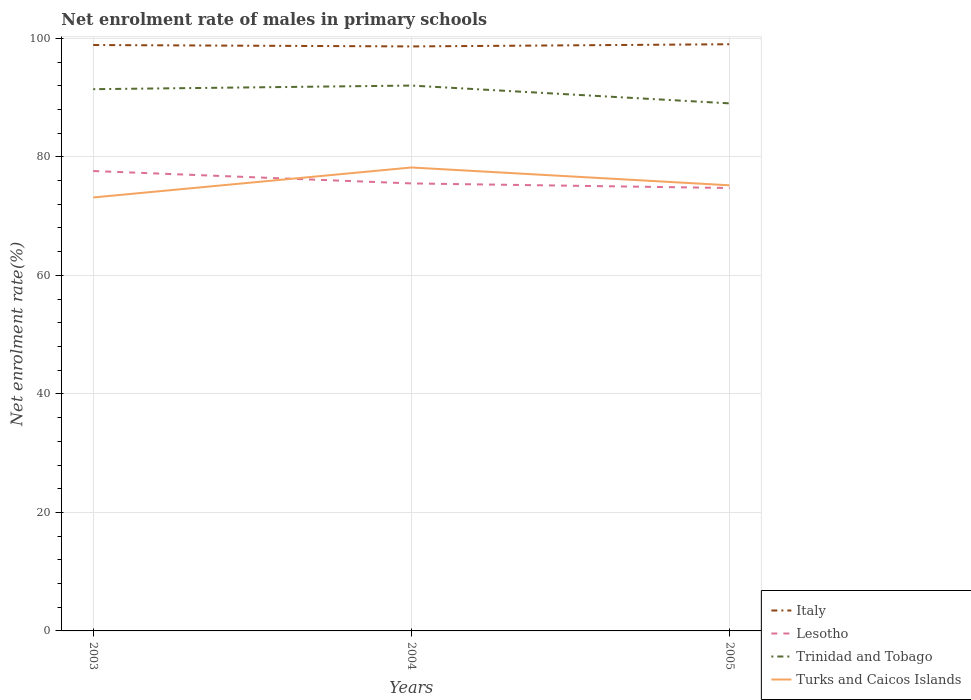How many different coloured lines are there?
Provide a short and direct response. 4. Is the number of lines equal to the number of legend labels?
Provide a short and direct response. Yes. Across all years, what is the maximum net enrolment rate of males in primary schools in Turks and Caicos Islands?
Offer a very short reply. 73.15. In which year was the net enrolment rate of males in primary schools in Turks and Caicos Islands maximum?
Your answer should be very brief. 2003. What is the total net enrolment rate of males in primary schools in Lesotho in the graph?
Make the answer very short. 2.1. What is the difference between the highest and the second highest net enrolment rate of males in primary schools in Turks and Caicos Islands?
Your response must be concise. 5.06. What is the difference between the highest and the lowest net enrolment rate of males in primary schools in Lesotho?
Keep it short and to the point. 1. Is the net enrolment rate of males in primary schools in Trinidad and Tobago strictly greater than the net enrolment rate of males in primary schools in Italy over the years?
Offer a terse response. Yes. How many years are there in the graph?
Provide a succinct answer. 3. What is the difference between two consecutive major ticks on the Y-axis?
Provide a short and direct response. 20. Are the values on the major ticks of Y-axis written in scientific E-notation?
Keep it short and to the point. No. Does the graph contain grids?
Make the answer very short. Yes. Where does the legend appear in the graph?
Provide a succinct answer. Bottom right. How many legend labels are there?
Ensure brevity in your answer.  4. What is the title of the graph?
Make the answer very short. Net enrolment rate of males in primary schools. Does "Burkina Faso" appear as one of the legend labels in the graph?
Your answer should be compact. No. What is the label or title of the X-axis?
Your answer should be very brief. Years. What is the label or title of the Y-axis?
Ensure brevity in your answer.  Net enrolment rate(%). What is the Net enrolment rate(%) in Italy in 2003?
Your answer should be very brief. 98.88. What is the Net enrolment rate(%) in Lesotho in 2003?
Offer a terse response. 77.62. What is the Net enrolment rate(%) of Trinidad and Tobago in 2003?
Provide a succinct answer. 91.43. What is the Net enrolment rate(%) in Turks and Caicos Islands in 2003?
Keep it short and to the point. 73.15. What is the Net enrolment rate(%) of Italy in 2004?
Give a very brief answer. 98.64. What is the Net enrolment rate(%) of Lesotho in 2004?
Provide a short and direct response. 75.52. What is the Net enrolment rate(%) in Trinidad and Tobago in 2004?
Provide a succinct answer. 92.04. What is the Net enrolment rate(%) of Turks and Caicos Islands in 2004?
Your answer should be compact. 78.21. What is the Net enrolment rate(%) of Italy in 2005?
Offer a terse response. 99.01. What is the Net enrolment rate(%) of Lesotho in 2005?
Provide a short and direct response. 74.75. What is the Net enrolment rate(%) in Trinidad and Tobago in 2005?
Offer a terse response. 89.03. What is the Net enrolment rate(%) of Turks and Caicos Islands in 2005?
Your answer should be very brief. 75.2. Across all years, what is the maximum Net enrolment rate(%) in Italy?
Your answer should be compact. 99.01. Across all years, what is the maximum Net enrolment rate(%) in Lesotho?
Your answer should be compact. 77.62. Across all years, what is the maximum Net enrolment rate(%) in Trinidad and Tobago?
Keep it short and to the point. 92.04. Across all years, what is the maximum Net enrolment rate(%) in Turks and Caicos Islands?
Make the answer very short. 78.21. Across all years, what is the minimum Net enrolment rate(%) in Italy?
Give a very brief answer. 98.64. Across all years, what is the minimum Net enrolment rate(%) in Lesotho?
Your answer should be very brief. 74.75. Across all years, what is the minimum Net enrolment rate(%) in Trinidad and Tobago?
Offer a terse response. 89.03. Across all years, what is the minimum Net enrolment rate(%) of Turks and Caicos Islands?
Provide a succinct answer. 73.15. What is the total Net enrolment rate(%) of Italy in the graph?
Your answer should be very brief. 296.53. What is the total Net enrolment rate(%) in Lesotho in the graph?
Your response must be concise. 227.89. What is the total Net enrolment rate(%) of Trinidad and Tobago in the graph?
Your answer should be compact. 272.5. What is the total Net enrolment rate(%) in Turks and Caicos Islands in the graph?
Your answer should be compact. 226.57. What is the difference between the Net enrolment rate(%) of Italy in 2003 and that in 2004?
Keep it short and to the point. 0.24. What is the difference between the Net enrolment rate(%) of Lesotho in 2003 and that in 2004?
Keep it short and to the point. 2.1. What is the difference between the Net enrolment rate(%) in Trinidad and Tobago in 2003 and that in 2004?
Provide a succinct answer. -0.61. What is the difference between the Net enrolment rate(%) in Turks and Caicos Islands in 2003 and that in 2004?
Ensure brevity in your answer.  -5.06. What is the difference between the Net enrolment rate(%) of Italy in 2003 and that in 2005?
Give a very brief answer. -0.13. What is the difference between the Net enrolment rate(%) in Lesotho in 2003 and that in 2005?
Provide a succinct answer. 2.87. What is the difference between the Net enrolment rate(%) of Trinidad and Tobago in 2003 and that in 2005?
Make the answer very short. 2.39. What is the difference between the Net enrolment rate(%) of Turks and Caicos Islands in 2003 and that in 2005?
Your answer should be compact. -2.05. What is the difference between the Net enrolment rate(%) in Italy in 2004 and that in 2005?
Make the answer very short. -0.37. What is the difference between the Net enrolment rate(%) in Lesotho in 2004 and that in 2005?
Provide a succinct answer. 0.77. What is the difference between the Net enrolment rate(%) of Trinidad and Tobago in 2004 and that in 2005?
Your response must be concise. 3. What is the difference between the Net enrolment rate(%) in Turks and Caicos Islands in 2004 and that in 2005?
Offer a terse response. 3.01. What is the difference between the Net enrolment rate(%) in Italy in 2003 and the Net enrolment rate(%) in Lesotho in 2004?
Your answer should be very brief. 23.36. What is the difference between the Net enrolment rate(%) in Italy in 2003 and the Net enrolment rate(%) in Trinidad and Tobago in 2004?
Provide a succinct answer. 6.84. What is the difference between the Net enrolment rate(%) in Italy in 2003 and the Net enrolment rate(%) in Turks and Caicos Islands in 2004?
Provide a short and direct response. 20.67. What is the difference between the Net enrolment rate(%) in Lesotho in 2003 and the Net enrolment rate(%) in Trinidad and Tobago in 2004?
Provide a succinct answer. -14.42. What is the difference between the Net enrolment rate(%) of Lesotho in 2003 and the Net enrolment rate(%) of Turks and Caicos Islands in 2004?
Make the answer very short. -0.59. What is the difference between the Net enrolment rate(%) in Trinidad and Tobago in 2003 and the Net enrolment rate(%) in Turks and Caicos Islands in 2004?
Your answer should be compact. 13.22. What is the difference between the Net enrolment rate(%) in Italy in 2003 and the Net enrolment rate(%) in Lesotho in 2005?
Your answer should be compact. 24.13. What is the difference between the Net enrolment rate(%) of Italy in 2003 and the Net enrolment rate(%) of Trinidad and Tobago in 2005?
Keep it short and to the point. 9.85. What is the difference between the Net enrolment rate(%) of Italy in 2003 and the Net enrolment rate(%) of Turks and Caicos Islands in 2005?
Offer a terse response. 23.68. What is the difference between the Net enrolment rate(%) in Lesotho in 2003 and the Net enrolment rate(%) in Trinidad and Tobago in 2005?
Your answer should be very brief. -11.42. What is the difference between the Net enrolment rate(%) of Lesotho in 2003 and the Net enrolment rate(%) of Turks and Caicos Islands in 2005?
Provide a short and direct response. 2.41. What is the difference between the Net enrolment rate(%) of Trinidad and Tobago in 2003 and the Net enrolment rate(%) of Turks and Caicos Islands in 2005?
Make the answer very short. 16.22. What is the difference between the Net enrolment rate(%) in Italy in 2004 and the Net enrolment rate(%) in Lesotho in 2005?
Offer a terse response. 23.89. What is the difference between the Net enrolment rate(%) in Italy in 2004 and the Net enrolment rate(%) in Trinidad and Tobago in 2005?
Your response must be concise. 9.61. What is the difference between the Net enrolment rate(%) of Italy in 2004 and the Net enrolment rate(%) of Turks and Caicos Islands in 2005?
Your answer should be very brief. 23.44. What is the difference between the Net enrolment rate(%) of Lesotho in 2004 and the Net enrolment rate(%) of Trinidad and Tobago in 2005?
Your response must be concise. -13.51. What is the difference between the Net enrolment rate(%) in Lesotho in 2004 and the Net enrolment rate(%) in Turks and Caicos Islands in 2005?
Give a very brief answer. 0.32. What is the difference between the Net enrolment rate(%) in Trinidad and Tobago in 2004 and the Net enrolment rate(%) in Turks and Caicos Islands in 2005?
Offer a very short reply. 16.83. What is the average Net enrolment rate(%) of Italy per year?
Your answer should be very brief. 98.84. What is the average Net enrolment rate(%) in Lesotho per year?
Make the answer very short. 75.96. What is the average Net enrolment rate(%) of Trinidad and Tobago per year?
Your answer should be very brief. 90.83. What is the average Net enrolment rate(%) of Turks and Caicos Islands per year?
Keep it short and to the point. 75.52. In the year 2003, what is the difference between the Net enrolment rate(%) in Italy and Net enrolment rate(%) in Lesotho?
Ensure brevity in your answer.  21.26. In the year 2003, what is the difference between the Net enrolment rate(%) of Italy and Net enrolment rate(%) of Trinidad and Tobago?
Offer a terse response. 7.45. In the year 2003, what is the difference between the Net enrolment rate(%) in Italy and Net enrolment rate(%) in Turks and Caicos Islands?
Ensure brevity in your answer.  25.73. In the year 2003, what is the difference between the Net enrolment rate(%) of Lesotho and Net enrolment rate(%) of Trinidad and Tobago?
Provide a short and direct response. -13.81. In the year 2003, what is the difference between the Net enrolment rate(%) of Lesotho and Net enrolment rate(%) of Turks and Caicos Islands?
Ensure brevity in your answer.  4.46. In the year 2003, what is the difference between the Net enrolment rate(%) of Trinidad and Tobago and Net enrolment rate(%) of Turks and Caicos Islands?
Give a very brief answer. 18.27. In the year 2004, what is the difference between the Net enrolment rate(%) of Italy and Net enrolment rate(%) of Lesotho?
Provide a short and direct response. 23.12. In the year 2004, what is the difference between the Net enrolment rate(%) in Italy and Net enrolment rate(%) in Trinidad and Tobago?
Make the answer very short. 6.61. In the year 2004, what is the difference between the Net enrolment rate(%) in Italy and Net enrolment rate(%) in Turks and Caicos Islands?
Give a very brief answer. 20.43. In the year 2004, what is the difference between the Net enrolment rate(%) of Lesotho and Net enrolment rate(%) of Trinidad and Tobago?
Give a very brief answer. -16.52. In the year 2004, what is the difference between the Net enrolment rate(%) of Lesotho and Net enrolment rate(%) of Turks and Caicos Islands?
Make the answer very short. -2.69. In the year 2004, what is the difference between the Net enrolment rate(%) of Trinidad and Tobago and Net enrolment rate(%) of Turks and Caicos Islands?
Offer a very short reply. 13.83. In the year 2005, what is the difference between the Net enrolment rate(%) in Italy and Net enrolment rate(%) in Lesotho?
Your answer should be very brief. 24.26. In the year 2005, what is the difference between the Net enrolment rate(%) in Italy and Net enrolment rate(%) in Trinidad and Tobago?
Offer a terse response. 9.98. In the year 2005, what is the difference between the Net enrolment rate(%) of Italy and Net enrolment rate(%) of Turks and Caicos Islands?
Make the answer very short. 23.81. In the year 2005, what is the difference between the Net enrolment rate(%) in Lesotho and Net enrolment rate(%) in Trinidad and Tobago?
Offer a terse response. -14.28. In the year 2005, what is the difference between the Net enrolment rate(%) in Lesotho and Net enrolment rate(%) in Turks and Caicos Islands?
Ensure brevity in your answer.  -0.45. In the year 2005, what is the difference between the Net enrolment rate(%) of Trinidad and Tobago and Net enrolment rate(%) of Turks and Caicos Islands?
Provide a short and direct response. 13.83. What is the ratio of the Net enrolment rate(%) of Italy in 2003 to that in 2004?
Ensure brevity in your answer.  1. What is the ratio of the Net enrolment rate(%) of Lesotho in 2003 to that in 2004?
Provide a short and direct response. 1.03. What is the ratio of the Net enrolment rate(%) of Trinidad and Tobago in 2003 to that in 2004?
Your response must be concise. 0.99. What is the ratio of the Net enrolment rate(%) of Turks and Caicos Islands in 2003 to that in 2004?
Your answer should be compact. 0.94. What is the ratio of the Net enrolment rate(%) in Italy in 2003 to that in 2005?
Your response must be concise. 1. What is the ratio of the Net enrolment rate(%) in Lesotho in 2003 to that in 2005?
Provide a short and direct response. 1.04. What is the ratio of the Net enrolment rate(%) of Trinidad and Tobago in 2003 to that in 2005?
Keep it short and to the point. 1.03. What is the ratio of the Net enrolment rate(%) in Turks and Caicos Islands in 2003 to that in 2005?
Provide a succinct answer. 0.97. What is the ratio of the Net enrolment rate(%) in Italy in 2004 to that in 2005?
Keep it short and to the point. 1. What is the ratio of the Net enrolment rate(%) of Lesotho in 2004 to that in 2005?
Your answer should be compact. 1.01. What is the ratio of the Net enrolment rate(%) in Trinidad and Tobago in 2004 to that in 2005?
Your response must be concise. 1.03. What is the difference between the highest and the second highest Net enrolment rate(%) of Italy?
Your response must be concise. 0.13. What is the difference between the highest and the second highest Net enrolment rate(%) of Lesotho?
Provide a short and direct response. 2.1. What is the difference between the highest and the second highest Net enrolment rate(%) of Trinidad and Tobago?
Offer a very short reply. 0.61. What is the difference between the highest and the second highest Net enrolment rate(%) in Turks and Caicos Islands?
Ensure brevity in your answer.  3.01. What is the difference between the highest and the lowest Net enrolment rate(%) in Italy?
Your response must be concise. 0.37. What is the difference between the highest and the lowest Net enrolment rate(%) in Lesotho?
Your answer should be very brief. 2.87. What is the difference between the highest and the lowest Net enrolment rate(%) of Trinidad and Tobago?
Keep it short and to the point. 3. What is the difference between the highest and the lowest Net enrolment rate(%) of Turks and Caicos Islands?
Offer a very short reply. 5.06. 